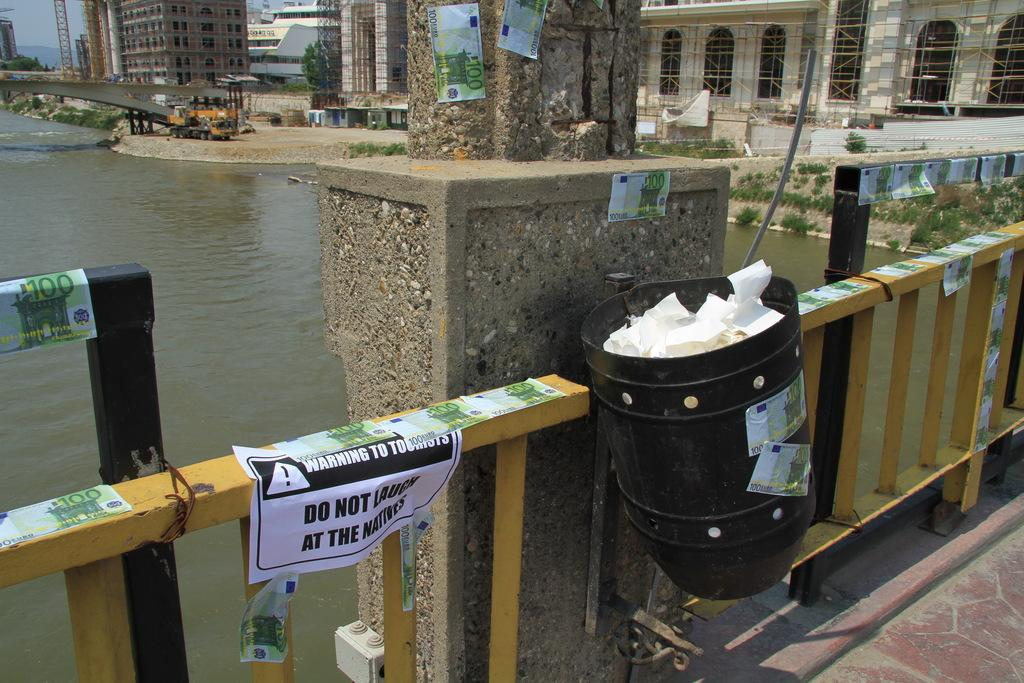Provide a one-sentence caption for the provided image. A bridge over a river with a paper sign that says Warning To Tourists. 